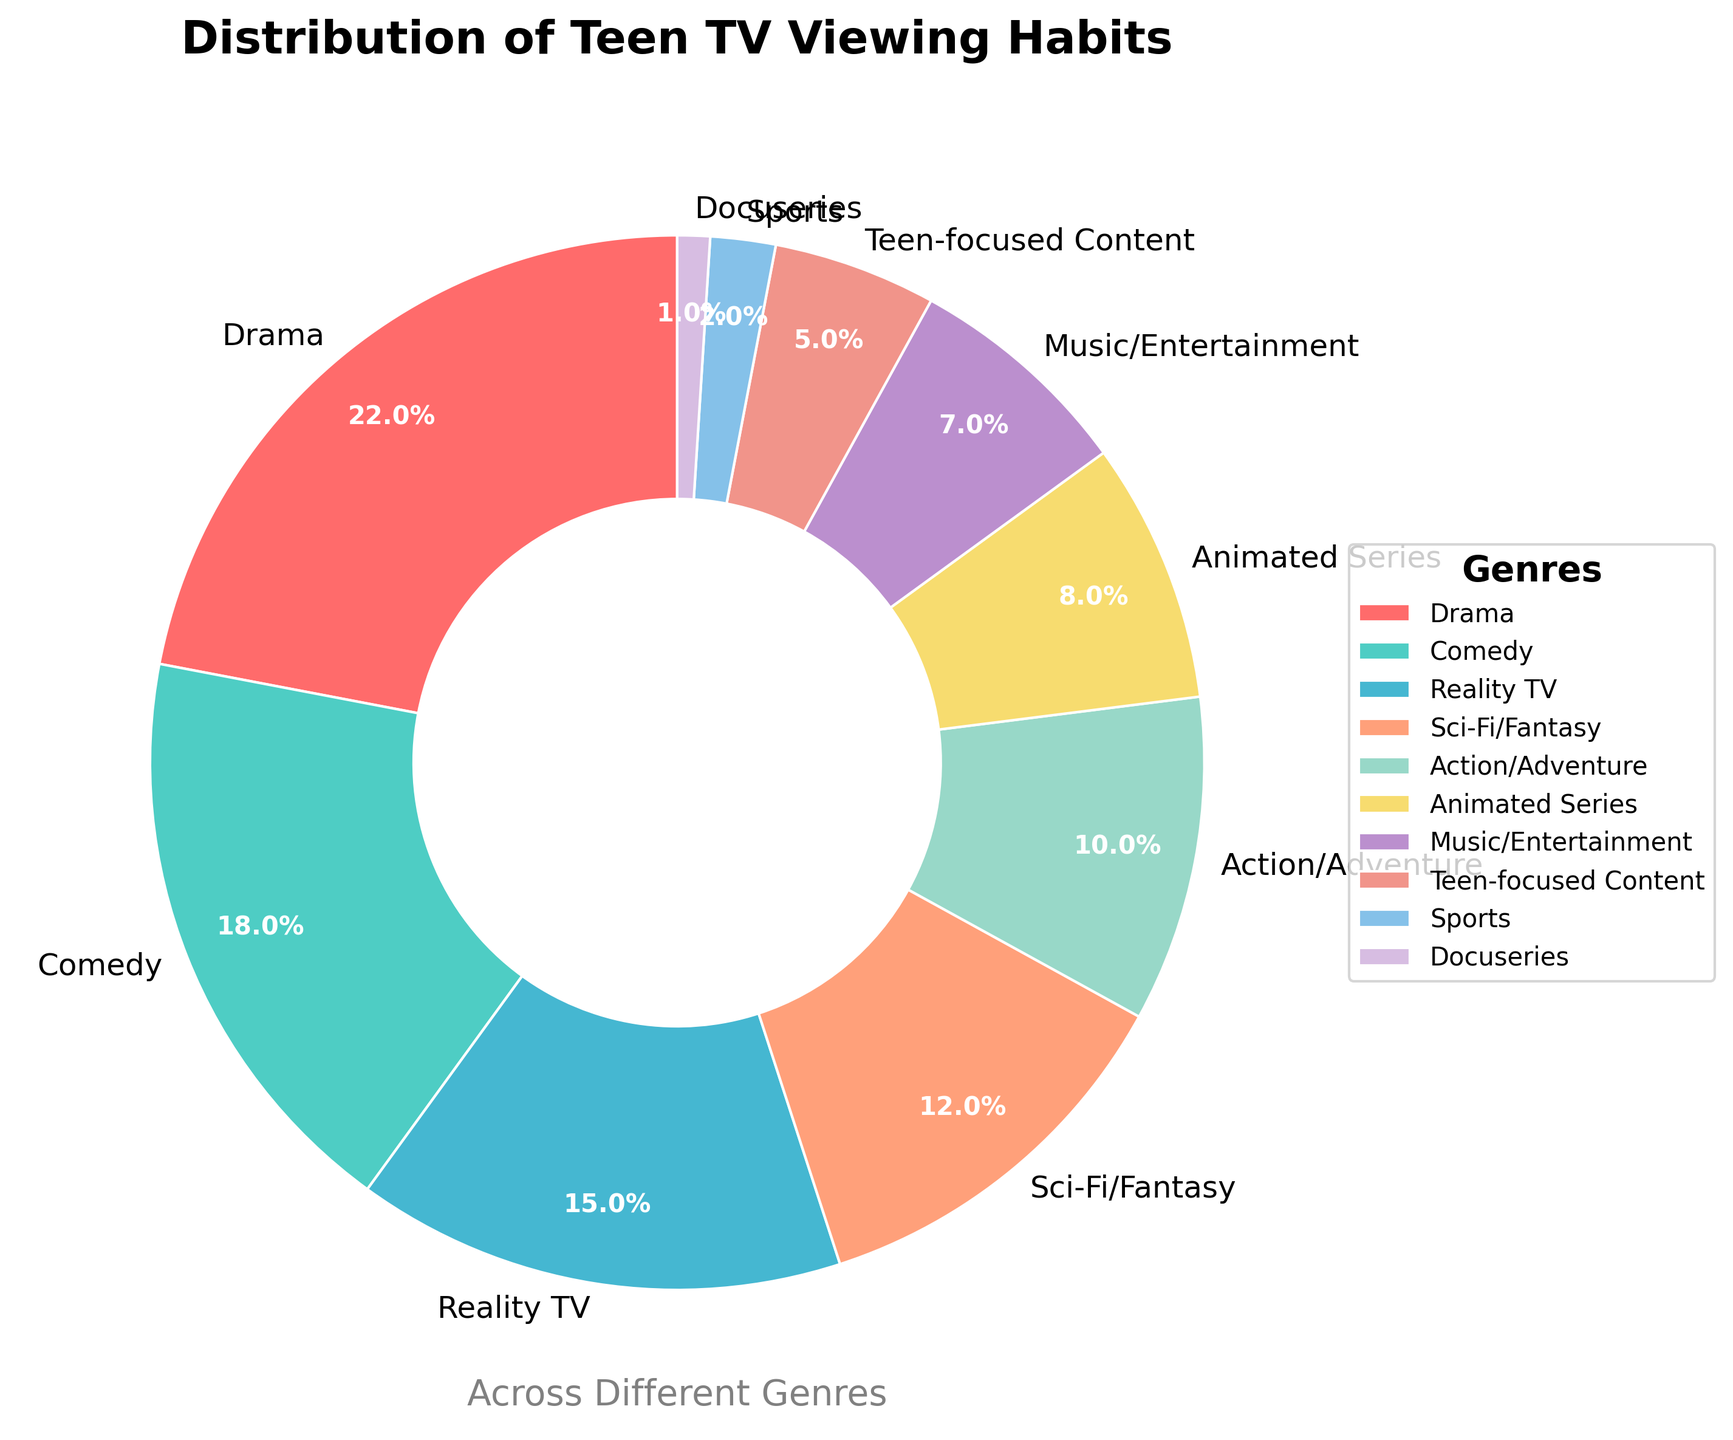Which genre has the highest percentage of teen TV viewing habits? The genre with the highest percentage is the one occupying the largest portion of the pie chart. From the chart, Drama has the highest percentage.
Answer: Drama Which genre has the lowest percentage of teen TV viewing habits? The genre with the lowest percentage is represented by the smallest slice in the pie chart. The smallest slice corresponds to Docuseries.
Answer: Docuseries What is the combined percentage of Comedy and Action/Adventure? To find the combined percentage, add the percentages of Comedy and Action/Adventure. Comedy is 18% and Action/Adventure is 10%, so the total is 18 + 10 = 28%.
Answer: 28% How much higher is the percentage of Drama compared to Animated Series? Subtract the percentage of Animated Series from Drama. Drama is 22% and Animated Series is 8%, so the difference is 22 - 8 = 14%.
Answer: 14% If you combine the percentages of all genres except Drama and Comedy, what is their total percentage? First, find the total percentage of all genres, which is 100%. Then, subtract the percentages of Drama and Comedy (22% and 18% respectively). 100 - 22 - 18 = 60%.
Answer: 60% Is the percentage of Reality TV greater than the percentage of Sci-Fi/Fantasy? Compare the percentages of Reality TV and Sci-Fi/Fantasy. Reality TV is 15% and Sci-Fi/Fantasy is 12%, so 15% > 12%.
Answer: Yes What is the average percentage of the three genres with the smallest slices? Identify the three smallest percentages: Docuseries (1%), Sports (2%), and Teen-focused Content (5%). Sum these percentages and divide by 3 to find the average: (1 + 2 + 5) / 3 = 2.67%.
Answer: 2.67% Which color is used for representing Comedy in the pie chart? Identify the section labeled Comedy and observe its color. Comedy is labeled with a segment colored in teal (greenish blue).
Answer: Teal How does the percentage of Music/Entertainment compare to Animated Series? Compare the percentages of Music/Entertainment (7%) and Animated Series (8%): 7% is slightly less than 8%.
Answer: Less What is the combined percentage of Reality TV, Sci-Fi/Fantasy, and Sports? Add the percentages of Reality TV (15%), Sci-Fi/Fantasy (12%), and Sports (2%). The combined percentage is 15 + 12 + 2 = 29%.
Answer: 29% 